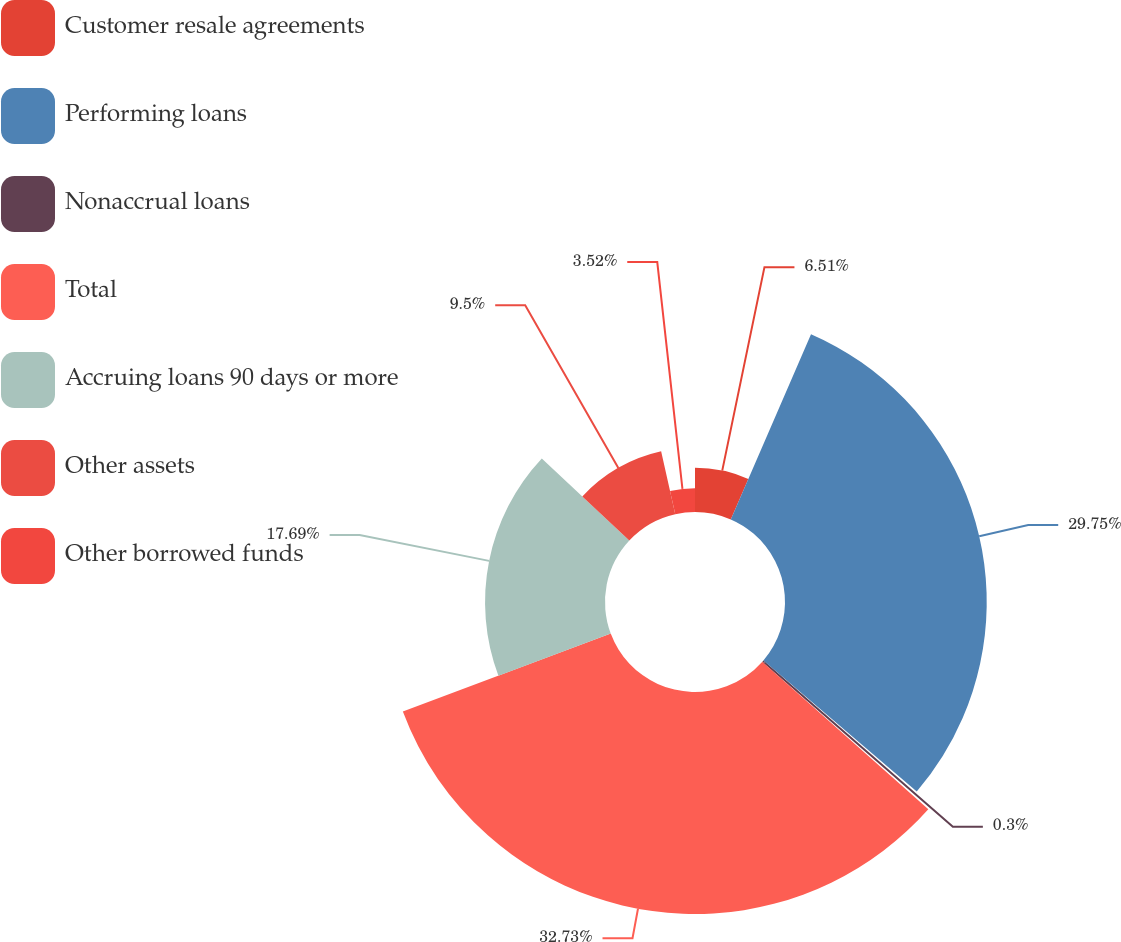Convert chart. <chart><loc_0><loc_0><loc_500><loc_500><pie_chart><fcel>Customer resale agreements<fcel>Performing loans<fcel>Nonaccrual loans<fcel>Total<fcel>Accruing loans 90 days or more<fcel>Other assets<fcel>Other borrowed funds<nl><fcel>6.51%<fcel>29.75%<fcel>0.3%<fcel>32.74%<fcel>17.69%<fcel>9.5%<fcel>3.52%<nl></chart> 